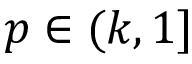<formula> <loc_0><loc_0><loc_500><loc_500>p \in ( k , 1 ]</formula> 